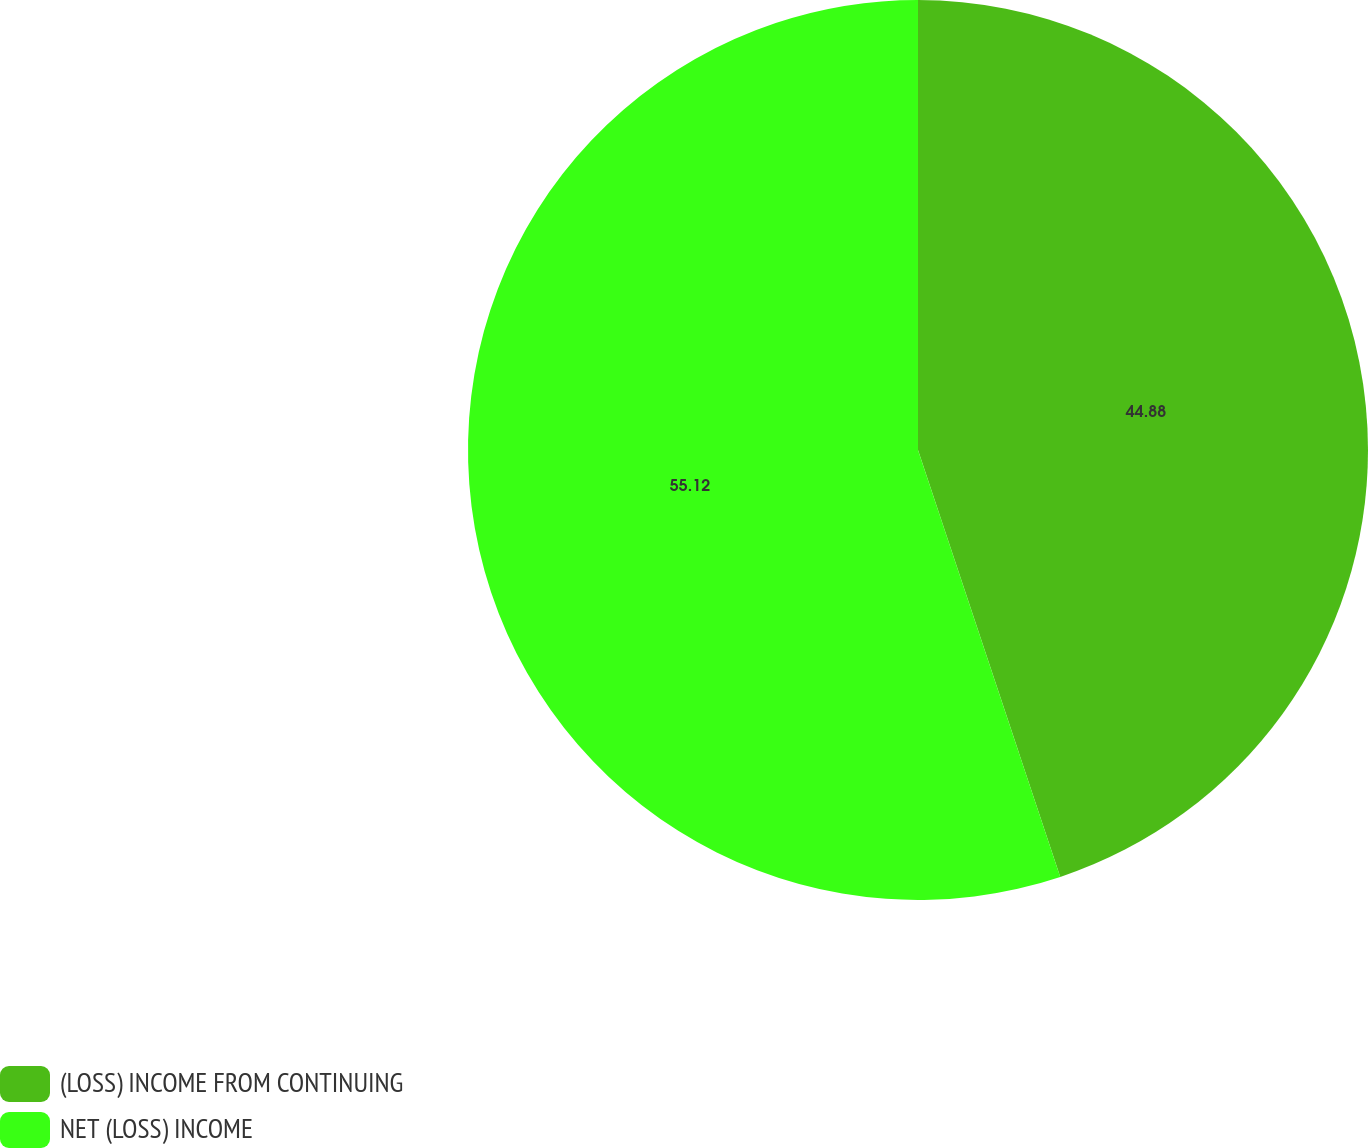<chart> <loc_0><loc_0><loc_500><loc_500><pie_chart><fcel>(LOSS) INCOME FROM CONTINUING<fcel>NET (LOSS) INCOME<nl><fcel>44.88%<fcel>55.12%<nl></chart> 